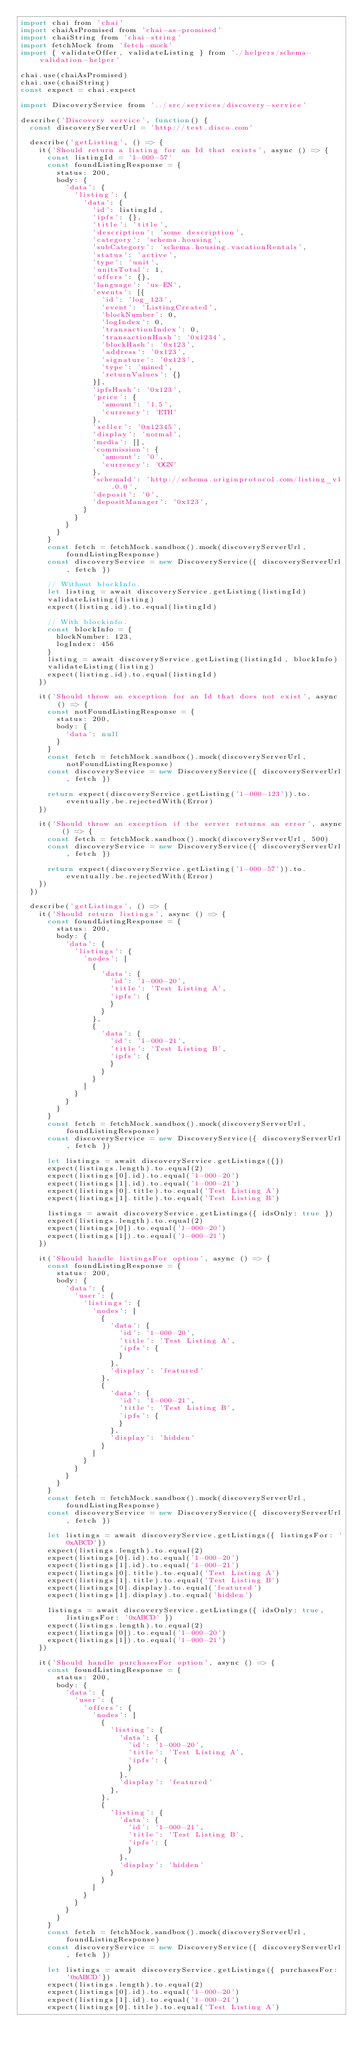Convert code to text. <code><loc_0><loc_0><loc_500><loc_500><_JavaScript_>import chai from 'chai'
import chaiAsPromised from 'chai-as-promised'
import chaiString from 'chai-string'
import fetchMock from 'fetch-mock'
import { validateOffer, validateListing } from './helpers/schema-validation-helper'

chai.use(chaiAsPromised)
chai.use(chaiString)
const expect = chai.expect

import DiscoveryService from '../src/services/discovery-service'

describe('Discovery service', function() {
  const discoveryServerUrl = 'http://test.disco.com'

  describe('getListing', () => {
    it('Should return a listing for an Id that exists', async () => {
      const listingId = '1-000-57'
      const foundListingResponse = {
        status: 200,
        body: {
          'data': {
            'listing': {
              'data': {
                'id': listingId,
                'ipfs': {},
                'title': 'title',
                'description': 'some description',
                'category': 'schema.housing',
                'subCategory': 'schema.housing.vacationRentals',
                'status': 'active',
                'type': 'unit',
                'unitsTotal': 1,
                'offers': {},
                'language': 'us-EN',
                'events': [{
                  'id': 'log_123',
                  'event': 'ListingCreated',
                  'blockNumber': 0,
                  'logIndex': 0,
                  'transactionIndex': 0,
                  'transactionHash': '0x1234',
                  'blockHash': '0x123',
                  'address': '0x123',
                  'signature': '0x123',
                  'type': 'mined',
                  'returnValues': {}
                }],
                'ipfsHash': '0x123',
                'price': {
                  'amount': '1.5',
                  'currency': 'ETH'
                },
                'seller': '0x12345',
                'display': 'normal',
                'media': [],
                'commission': {
                  'amount': '0',
                  'currency': 'OGN'
                },
                'schemaId': 'http://schema.originprotocol.com/listing_v1.0.0',
                'deposit': '0',
                'depositManager': '0x123',
              }
            }
          }
        }
      }
      const fetch = fetchMock.sandbox().mock(discoveryServerUrl, foundListingResponse)
      const discoveryService = new DiscoveryService({ discoveryServerUrl, fetch })

      // Without blockInfo.
      let listing = await discoveryService.getListing(listingId)
      validateListing(listing)
      expect(listing.id).to.equal(listingId)

      // With blockinfo.
      const blockInfo = {
        blockNumber: 123,
        logIndex: 456
      }
      listing = await discoveryService.getListing(listingId, blockInfo)
      validateListing(listing)
      expect(listing.id).to.equal(listingId)
    })

    it('Should throw an exception for an Id that does not exist', async () => {
      const notFoundListingResponse = {
        status: 200,
        body: {
          'data': null
        }
      }
      const fetch = fetchMock.sandbox().mock(discoveryServerUrl, notFoundListingResponse)
      const discoveryService = new DiscoveryService({ discoveryServerUrl, fetch })

      return expect(discoveryService.getListing('1-000-123')).to.eventually.be.rejectedWith(Error)
    })

    it('Should throw an exception if the server returns an error', async () => {
      const fetch = fetchMock.sandbox().mock(discoveryServerUrl, 500)
      const discoveryService = new DiscoveryService({ discoveryServerUrl, fetch })

      return expect(discoveryService.getListing('1-000-57')).to.eventually.be.rejectedWith(Error)
    })
  })

  describe('getListings', () => {
    it('Should return listings', async () => {
      const foundListingResponse = {
        status: 200,
        body: {
          'data': {
            'listings': {
              'nodes': [
                {
                  'data': {
                    'id': '1-000-20',
                    'title': 'Test Listing A',
                    'ipfs': {
                    }
                  }
                },
                {
                  'data': {
                    'id': '1-000-21',
                    'title': 'Test Listing B',
                    'ipfs': {
                    }
                  }
                }
              ]
            }
          }
        }
      }
      const fetch = fetchMock.sandbox().mock(discoveryServerUrl, foundListingResponse)
      const discoveryService = new DiscoveryService({ discoveryServerUrl, fetch })

      let listings = await discoveryService.getListings({})
      expect(listings.length).to.equal(2)
      expect(listings[0].id).to.equal('1-000-20')
      expect(listings[1].id).to.equal('1-000-21')
      expect(listings[0].title).to.equal('Test Listing A')
      expect(listings[1].title).to.equal('Test Listing B')

      listings = await discoveryService.getListings({ idsOnly: true })
      expect(listings.length).to.equal(2)
      expect(listings[0]).to.equal('1-000-20')
      expect(listings[1]).to.equal('1-000-21')
    })

    it('Should handle listingsFor option', async () => {
      const foundListingResponse = {
        status: 200,
        body: {
          'data': {
            'user': {
              'listings': {
                'nodes': [
                  {
                    'data': {
                      'id': '1-000-20',
                      'title': 'Test Listing A',
                      'ipfs': {
                      }
                    },
                    'display': 'featured'
                  },
                  {
                    'data': {
                      'id': '1-000-21',
                      'title': 'Test Listing B',
                      'ipfs': {
                      }
                    },
                    'display': 'hidden'
                  }
                ]
              }
            }
          }
        }
      }
      const fetch = fetchMock.sandbox().mock(discoveryServerUrl, foundListingResponse)
      const discoveryService = new DiscoveryService({ discoveryServerUrl, fetch })

      let listings = await discoveryService.getListings({ listingsFor: '0xABCD'})
      expect(listings.length).to.equal(2)
      expect(listings[0].id).to.equal('1-000-20')
      expect(listings[1].id).to.equal('1-000-21')
      expect(listings[0].title).to.equal('Test Listing A')
      expect(listings[1].title).to.equal('Test Listing B')
      expect(listings[0].display).to.equal('featured')
      expect(listings[1].display).to.equal('hidden')

      listings = await discoveryService.getListings({ idsOnly: true, listingsFor: '0xABCD' })
      expect(listings.length).to.equal(2)
      expect(listings[0]).to.equal('1-000-20')
      expect(listings[1]).to.equal('1-000-21')
    })

    it('Should handle purchasesFor option', async () => {
      const foundListingResponse = {
        status: 200,
        body: {
          'data': {
            'user': {
              'offers': {
                'nodes': [
                  {
                    'listing': {
                      'data': {
                        'id': '1-000-20',
                        'title': 'Test Listing A',
                        'ipfs': {
                        }
                      },
                      'display': 'featured'
                    },
                  },
                  {
                    'listing': {
                      'data': {
                        'id': '1-000-21',
                        'title': 'Test Listing B',
                        'ipfs': {
                        }
                      },
                      'display': 'hidden'
                    }
                  }
                ]
              }
            }
          }
        }
      }
      const fetch = fetchMock.sandbox().mock(discoveryServerUrl, foundListingResponse)
      const discoveryService = new DiscoveryService({ discoveryServerUrl, fetch })

      let listings = await discoveryService.getListings({ purchasesFor: '0xABCD'})
      expect(listings.length).to.equal(2)
      expect(listings[0].id).to.equal('1-000-20')
      expect(listings[1].id).to.equal('1-000-21')
      expect(listings[0].title).to.equal('Test Listing A')</code> 